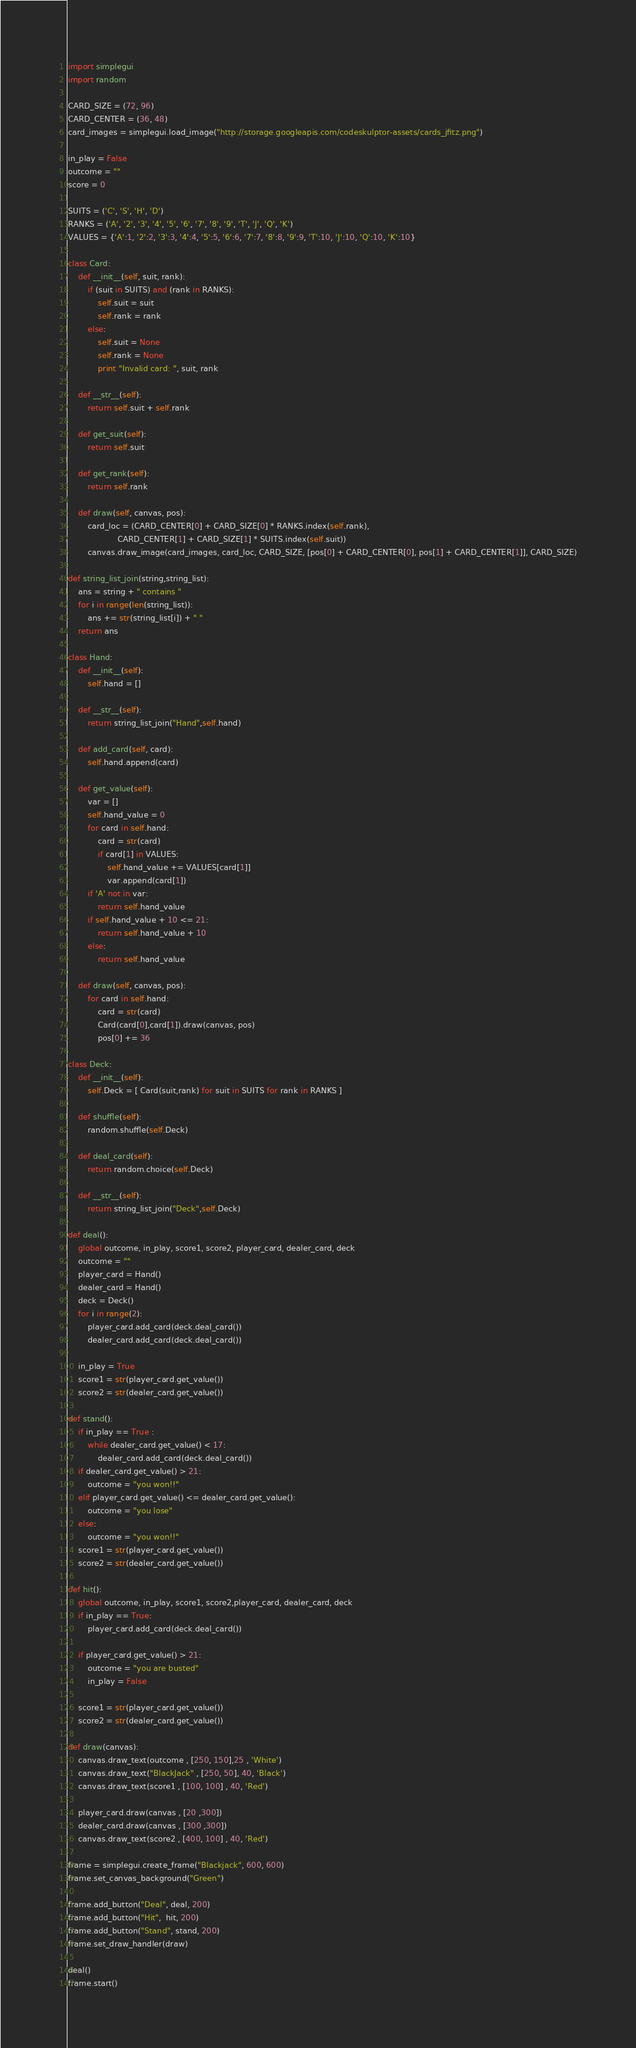Convert code to text. <code><loc_0><loc_0><loc_500><loc_500><_Python_>import simplegui
import random

CARD_SIZE = (72, 96)
CARD_CENTER = (36, 48)
card_images = simplegui.load_image("http://storage.googleapis.com/codeskulptor-assets/cards_jfitz.png")    

in_play = False
outcome = ""
score = 0

SUITS = ('C', 'S', 'H', 'D')
RANKS = ('A', '2', '3', '4', '5', '6', '7', '8', '9', 'T', 'J', 'Q', 'K')
VALUES = {'A':1, '2':2, '3':3, '4':4, '5':5, '6':6, '7':7, '8':8, '9':9, 'T':10, 'J':10, 'Q':10, 'K':10}

class Card:
    def __init__(self, suit, rank):
        if (suit in SUITS) and (rank in RANKS):
            self.suit = suit
            self.rank = rank
        else:
            self.suit = None
            self.rank = None
            print "Invalid card: ", suit, rank

    def __str__(self):
        return self.suit + self.rank

    def get_suit(self):
        return self.suit

    def get_rank(self):
        return self.rank

    def draw(self, canvas, pos):
        card_loc = (CARD_CENTER[0] + CARD_SIZE[0] * RANKS.index(self.rank), 
                    CARD_CENTER[1] + CARD_SIZE[1] * SUITS.index(self.suit))
        canvas.draw_image(card_images, card_loc, CARD_SIZE, [pos[0] + CARD_CENTER[0], pos[1] + CARD_CENTER[1]], CARD_SIZE)

def string_list_join(string,string_list):
    ans = string + " contains "
    for i in range(len(string_list)):
        ans += str(string_list[i]) + " "
    return ans

class Hand:
    def __init__(self):
        self.hand = []

    def __str__(self):
        return string_list_join("Hand",self.hand)

    def add_card(self, card):
        self.hand.append(card)

    def get_value(self):
        var = []
        self.hand_value = 0
        for card in self.hand:
            card = str(card)
            if card[1] in VALUES:
                self.hand_value += VALUES[card[1]]
                var.append(card[1])
        if 'A' not in var:
            return self.hand_value
        if self.hand_value + 10 <= 21:
            return self.hand_value + 10
        else:
            return self.hand_value         
   
    def draw(self, canvas, pos):
        for card in self.hand:
            card = str(card)
            Card(card[0],card[1]).draw(canvas, pos)
            pos[0] += 36
    
class Deck:
    def __init__(self):
        self.Deck = [ Card(suit,rank) for suit in SUITS for rank in RANKS ]

    def shuffle(self):
        random.shuffle(self.Deck)

    def deal_card(self):
        return random.choice(self.Deck)
    
    def __str__(self):
        return string_list_join("Deck",self.Deck)

def deal():
    global outcome, in_play, score1, score2, player_card, dealer_card, deck
    outcome = ""
    player_card = Hand()
    dealer_card = Hand()
    deck = Deck()
    for i in range(2):
        player_card.add_card(deck.deal_card())  
        dealer_card.add_card(deck.deal_card()) 
    
    in_play = True
    score1 = str(player_card.get_value())
    score2 = str(dealer_card.get_value())
    
def stand():
    if in_play == True :
        while dealer_card.get_value() < 17:
            dealer_card.add_card(deck.deal_card()) 
    if dealer_card.get_value() > 21:
        outcome = "you won!!"
    elif player_card.get_value() <= dealer_card.get_value():
        outcome = "you lose"
    else:
        outcome = "you won!!"
    score1 = str(player_card.get_value())
    score2 = str(dealer_card.get_value())

def hit():
    global outcome, in_play, score1, score2,player_card, dealer_card, deck
    if in_play == True:
        player_card.add_card(deck.deal_card()) 
        
    if player_card.get_value() > 21:
        outcome = "you are busted"
        in_play = False
        
    score1 = str(player_card.get_value())
    score2 = str(dealer_card.get_value())
   
def draw(canvas):
    canvas.draw_text(outcome , [250, 150],25 , 'White')
    canvas.draw_text("BlackJack" , [250, 50], 40, 'Black')
    canvas.draw_text(score1 , [100, 100] , 40, 'Red')
    
    player_card.draw(canvas , [20 ,300])
    dealer_card.draw(canvas , [300 ,300]) 
    canvas.draw_text(score2 , [400, 100] , 40, 'Red')

frame = simplegui.create_frame("Blackjack", 600, 600)
frame.set_canvas_background("Green")

frame.add_button("Deal", deal, 200)
frame.add_button("Hit",  hit, 200)
frame.add_button("Stand", stand, 200)
frame.set_draw_handler(draw)

deal()
frame.start()
</code> 